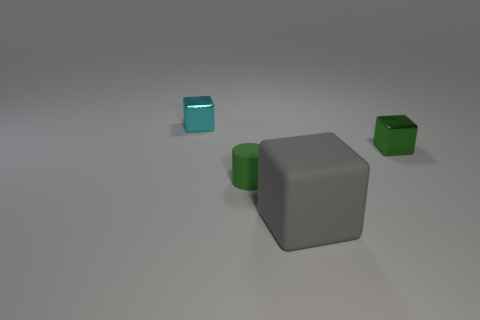What can you infer about the setting of this scene? The setting seems to be a neutral, seamless background which is often used in visualizations to focus attention solely on the objects without any distractions. The lack of any additional reference points or features suggests that this environment was chosen to highlight the objects unambiguously. 